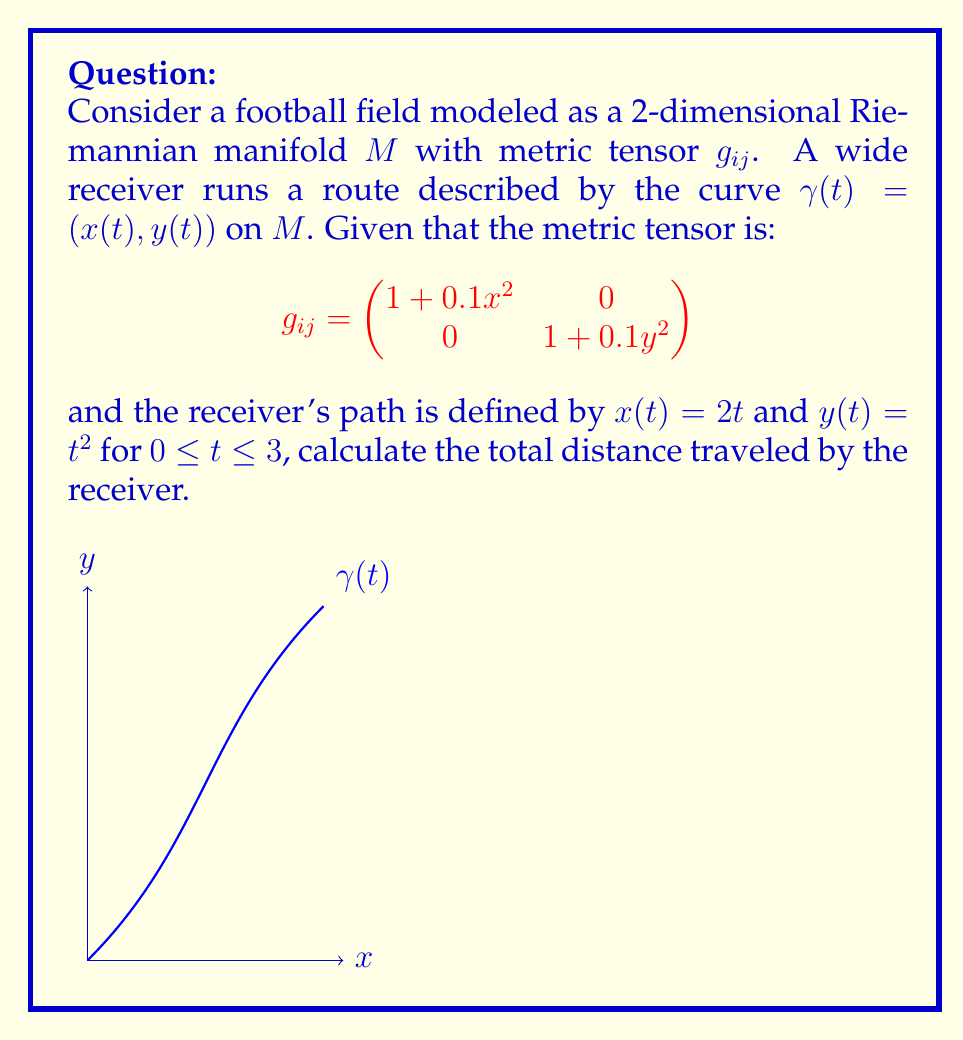Solve this math problem. To solve this problem, we need to follow these steps:

1) The distance traveled along a curve $\gamma(t)$ on a Riemannian manifold is given by the arc length formula:

   $$L = \int_{0}^{3} \sqrt{g_{ij}\frac{d\gamma^i}{dt}\frac{d\gamma^j}{dt}} dt$$

2) We need to calculate $\frac{d\gamma^i}{dt}$:
   $\frac{dx}{dt} = 2$, $\frac{dy}{dt} = 2t$

3) Now, let's substitute these into the arc length formula:

   $$L = \int_{0}^{3} \sqrt{(1+0.1x^2)(2)^2 + (1+0.1y^2)(2t)^2} dt$$

4) Substitute $x = 2t$ and $y = t^2$:

   $$L = \int_{0}^{3} \sqrt{(1+0.1(2t)^2)(4) + (1+0.1t^4)(4t^2)} dt$$

5) Simplify:

   $$L = \int_{0}^{3} \sqrt{4+1.6t^2 + 4t^2+0.4t^6} dt$$
   $$L = \int_{0}^{3} \sqrt{4+5.6t^2+0.4t^6} dt$$

6) This integral doesn't have a simple closed form. We need to evaluate it numerically.

7) Using numerical integration methods (like Simpson's rule or adaptive quadrature), we can approximate the value of this integral.
Answer: $\approx 10.76$ units 